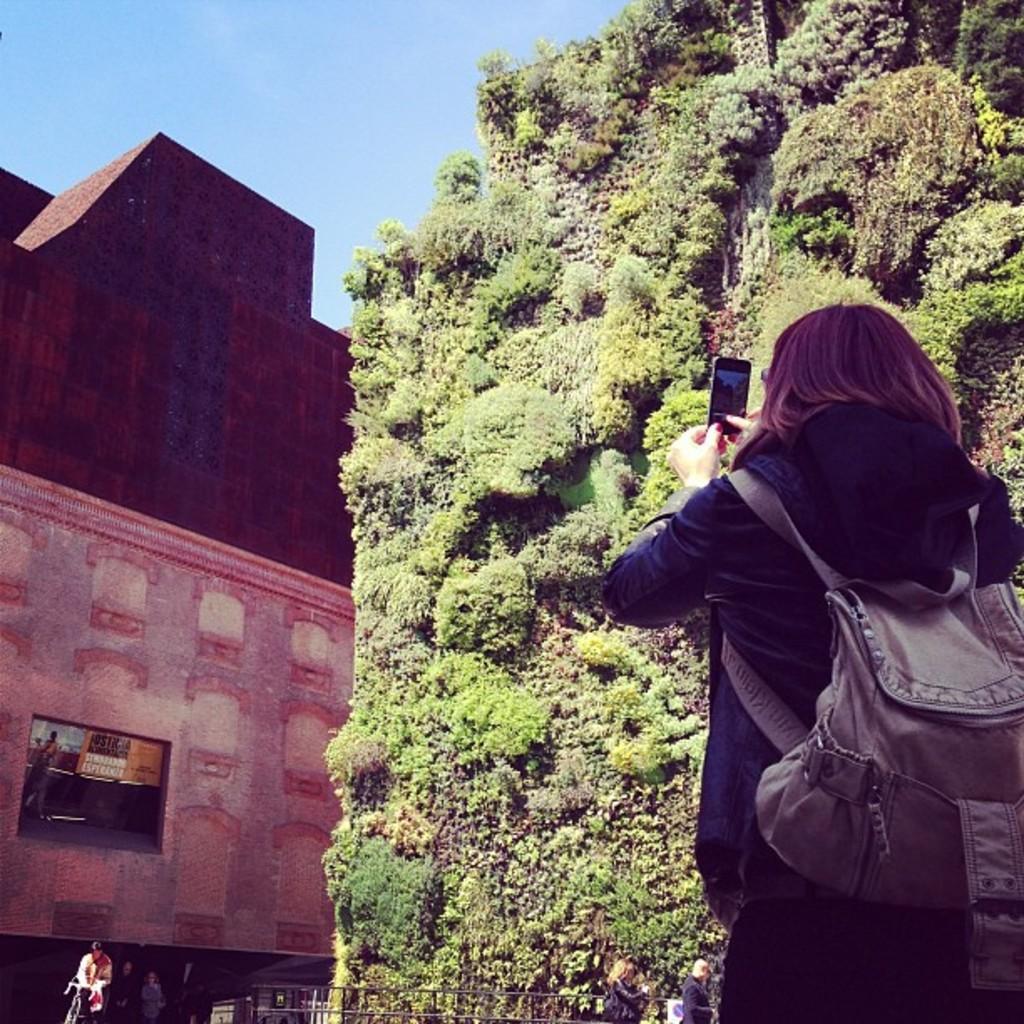Please provide a concise description of this image. In this picture we can see a person carrying a bag and holding a mobile and in front of this person we can see a building, plants, fence, some people and in the background we can see the sky. 